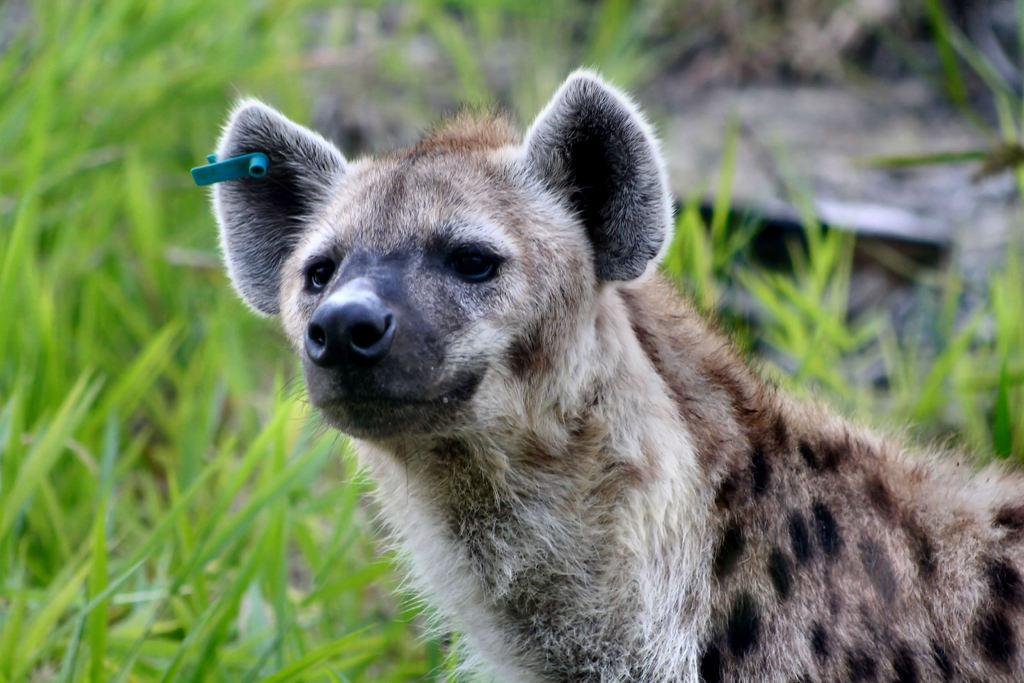What animal is in the middle of the picture? There is a hyena in the middle of the picture. What type of vegetation can be seen in the background of the picture? There is grass visible in the background of the picture. What type of education does the fowl in the picture have? There is no fowl present in the image, so it is not possible to determine its level of education. 